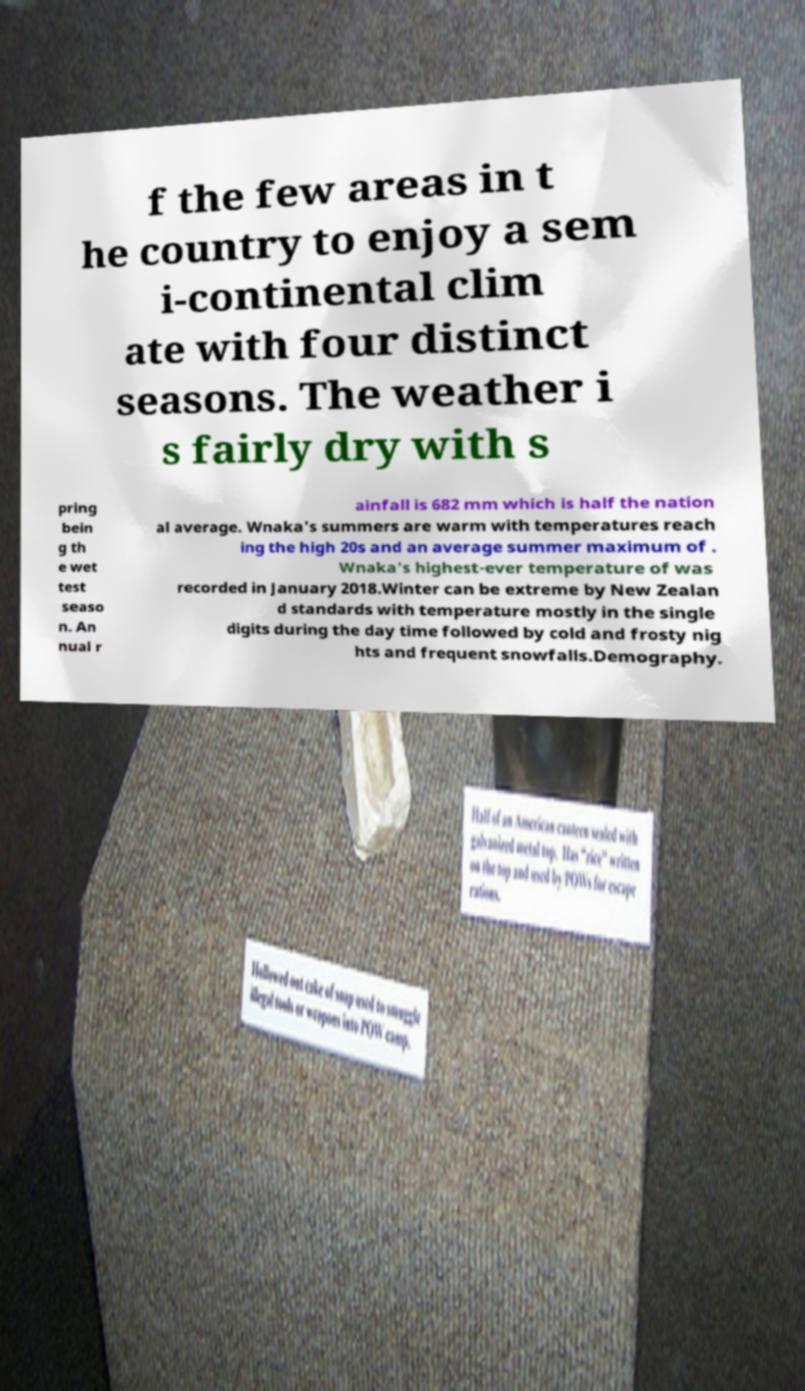I need the written content from this picture converted into text. Can you do that? f the few areas in t he country to enjoy a sem i-continental clim ate with four distinct seasons. The weather i s fairly dry with s pring bein g th e wet test seaso n. An nual r ainfall is 682 mm which is half the nation al average. Wnaka's summers are warm with temperatures reach ing the high 20s and an average summer maximum of . Wnaka's highest-ever temperature of was recorded in January 2018.Winter can be extreme by New Zealan d standards with temperature mostly in the single digits during the day time followed by cold and frosty nig hts and frequent snowfalls.Demography. 